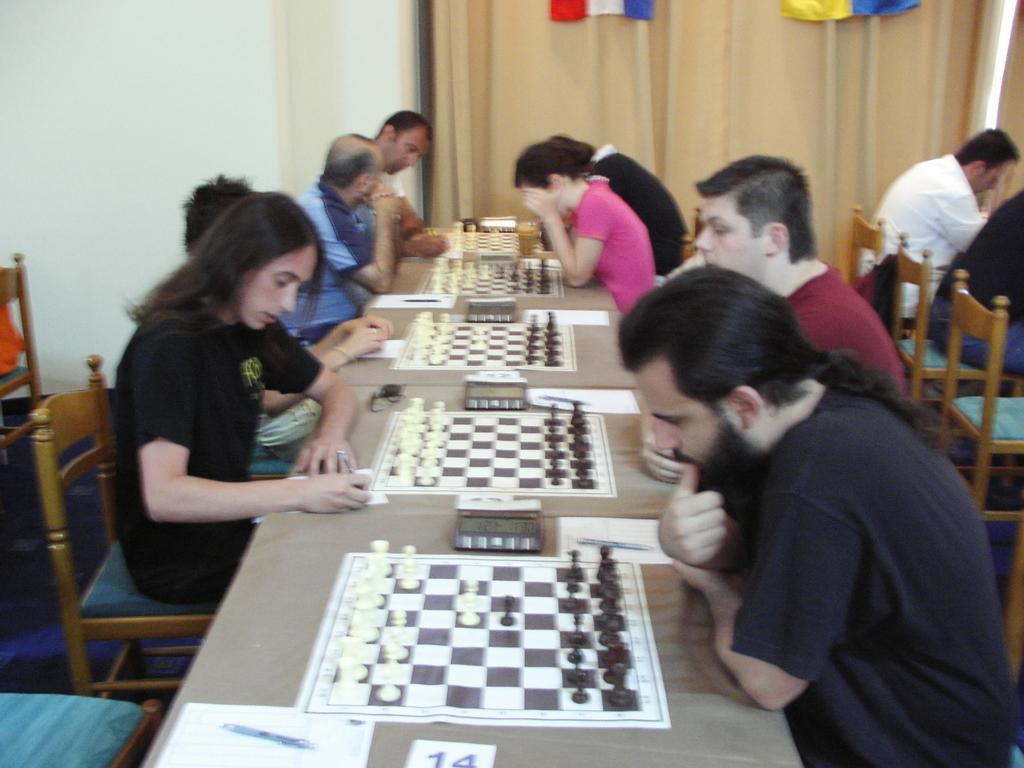Could you give a brief overview of what you see in this image? There are so many people sitting on either sides of chair playing chess on chess board. 